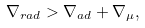<formula> <loc_0><loc_0><loc_500><loc_500>\nabla _ { r a d } > \nabla _ { a d } + \nabla _ { \mu } ,</formula> 